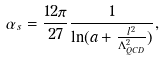<formula> <loc_0><loc_0><loc_500><loc_500>\alpha _ { s } = \frac { 1 2 \pi } { 2 7 } \frac { 1 } { \ln ( a + \frac { l ^ { 2 } } { \Lambda ^ { 2 } _ { Q C D } } ) } ,</formula> 